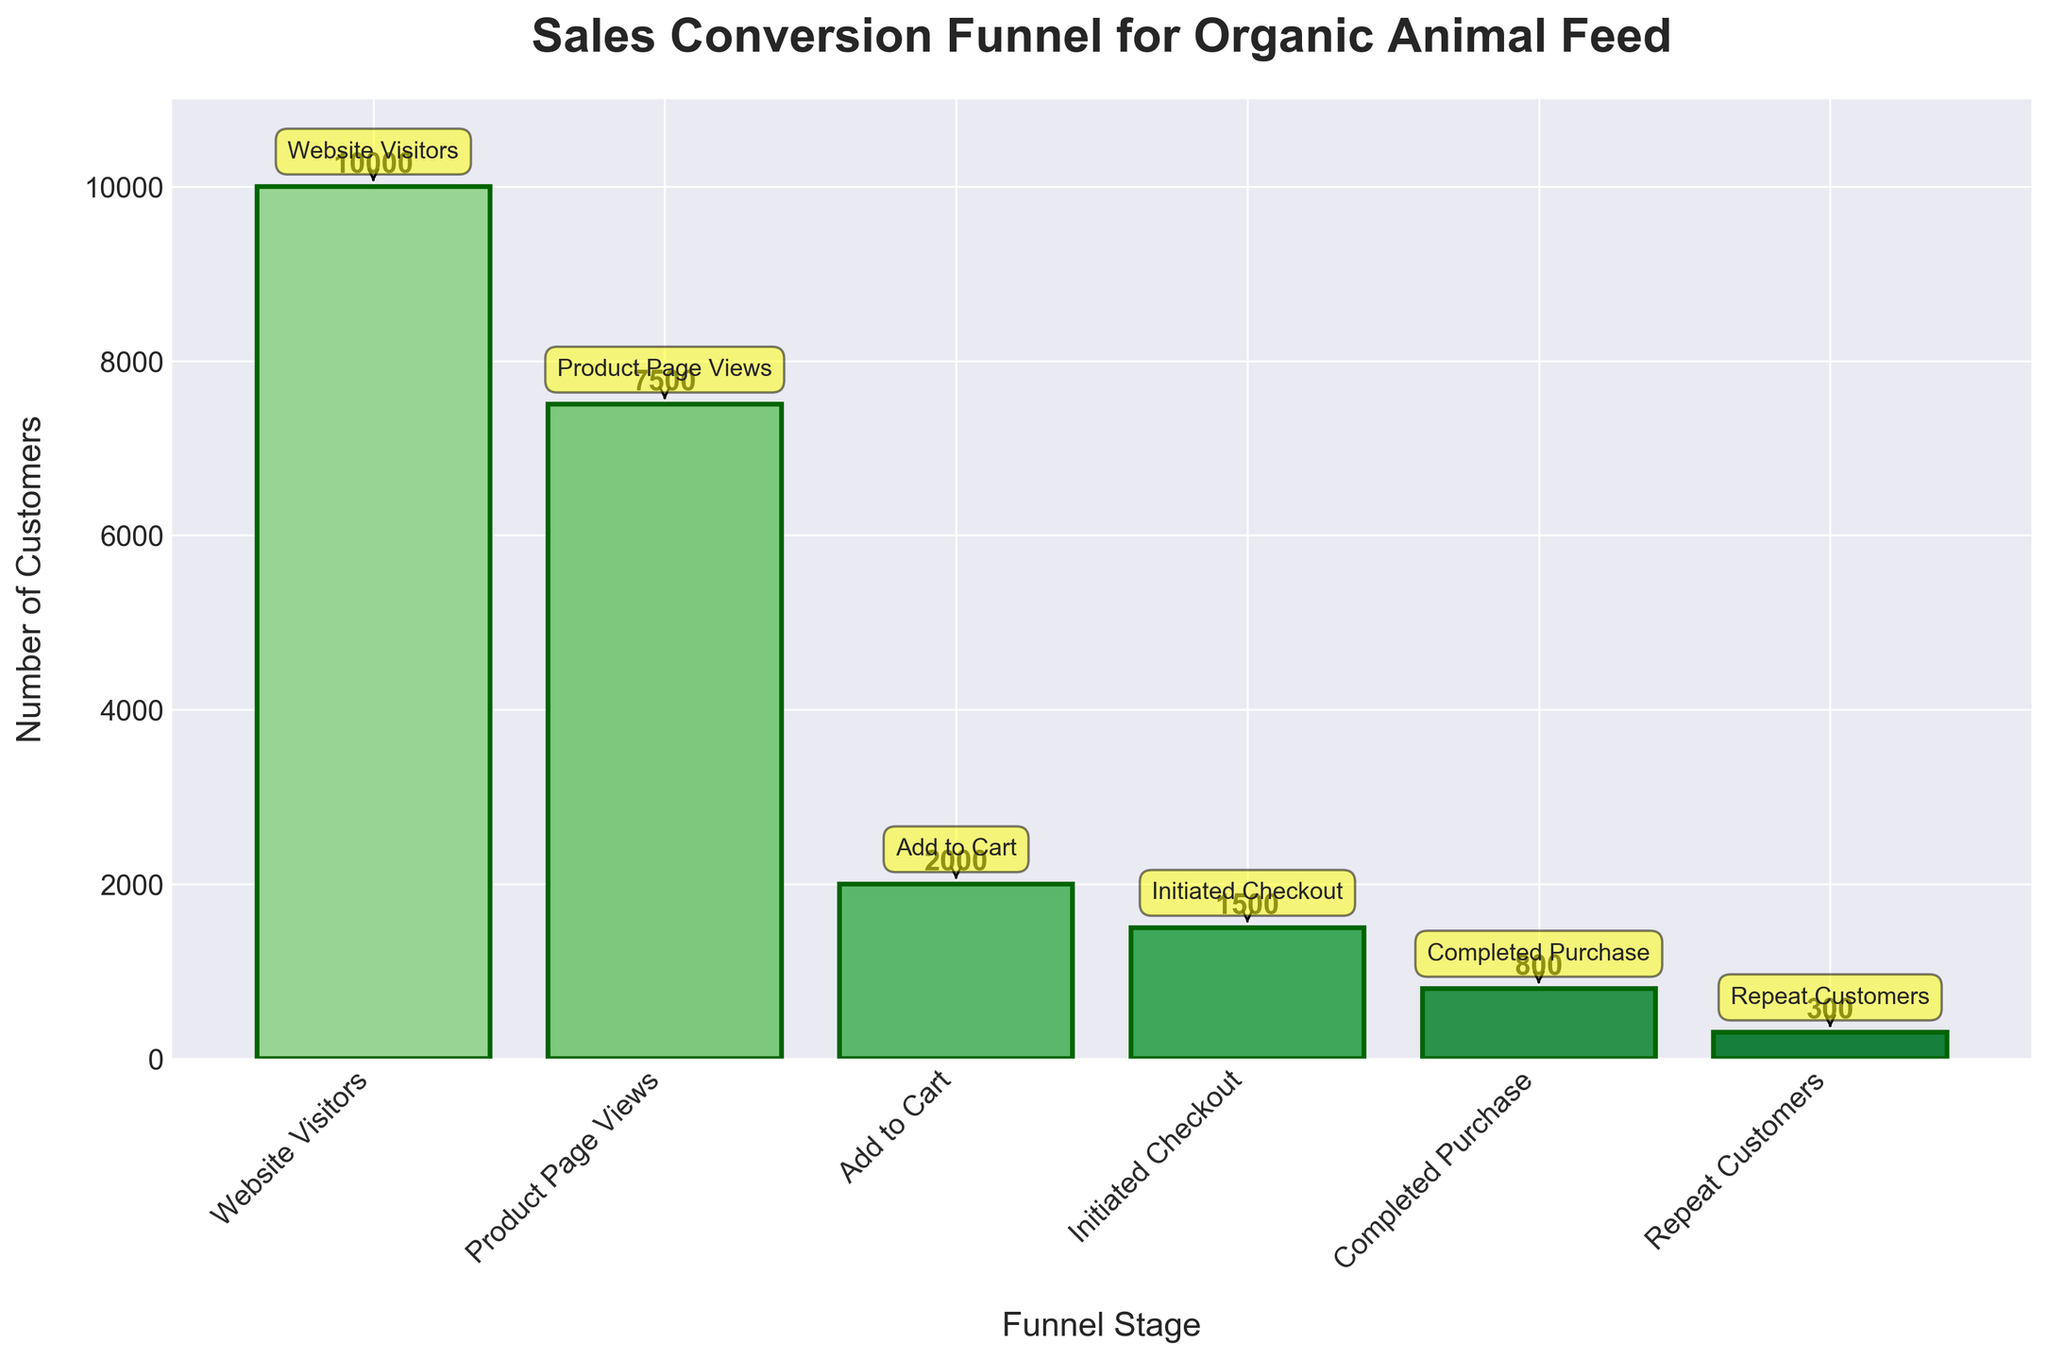What is the title of the chart? The title is prominently displayed at the top of the chart and reads "Sales Conversion Funnel for Organic Animal Feed".
Answer: Sales Conversion Funnel for Organic Animal Feed How many stages are there in the sales funnel? The x-axis labels indicate there are six stages listed: Website Visitors, Product Page Views, Add to Cart, Initiated Checkout, Completed Purchase, and Repeat Customers.
Answer: Six What is the number of Website Visitors? Looking at the first bar from the left, the count displayed above it is 10,000.
Answer: 10,000 How many customers completed the purchase after adding products to the cart? Subtract the number of Completed Purchase (800) from Add to Cart (2,000). The difference gives us the number of customers who completed the purchase after adding items. 2,000 - 800 = 1,200.
Answer: 1,200 Which stage has the largest drop in the number of customers? Comparing each subsequent stage, the largest drop occurs between Product Page Views (7,500) and Add to Cart (2,000), with a difference of 7,500 - 2,000 = 5,500.
Answer: Product Page Views to Add to Cart What is the total number of customers who visited the website but did not complete a purchase? Subtract the number of Completed Purchase (800) from Website Visitors (10,000). The difference is 10,000 - 800 = 9,200.
Answer: 9,200 How many customers initiate checkout but do not complete the purchase? Subtract the number of Completed Purchase (800) from Initiated Checkout (1,500). The difference is 1,500 - 800 = 700.
Answer: 700 What percentage of website visitors completed a purchase? Divide Completed Purchase (800) by Website Visitors (10,000) and multiply by 100 to get the percentage. (800 / 10,000) * 100 = 8%.
Answer: 8% Between which two consecutive stages is the conversion rate the highest? Calculate the conversion rates between consecutive stages and identify the highest one. For example:
- Product Page Views to Add to Cart: (2,000 / 7,500) * 100 = ~26.67%
- Add to Cart to Initiated Checkout: (1,500 / 2,000) * 100 = 75%
- Initiated Checkout to Completed Purchase: (800 / 1,500) * 100 = ~53.33%
The highest conversion rate is from Add to Cart to Initiated Checkout (75%).
Answer: Add to Cart to Initiated Checkout What is the number of repeat customers as a percentage of completed purchases? Divide Repeat Customers (300) by Completed Purchase (800) and multiply by 100. (300 / 800) * 100 = 37.5%.
Answer: 37.5% 